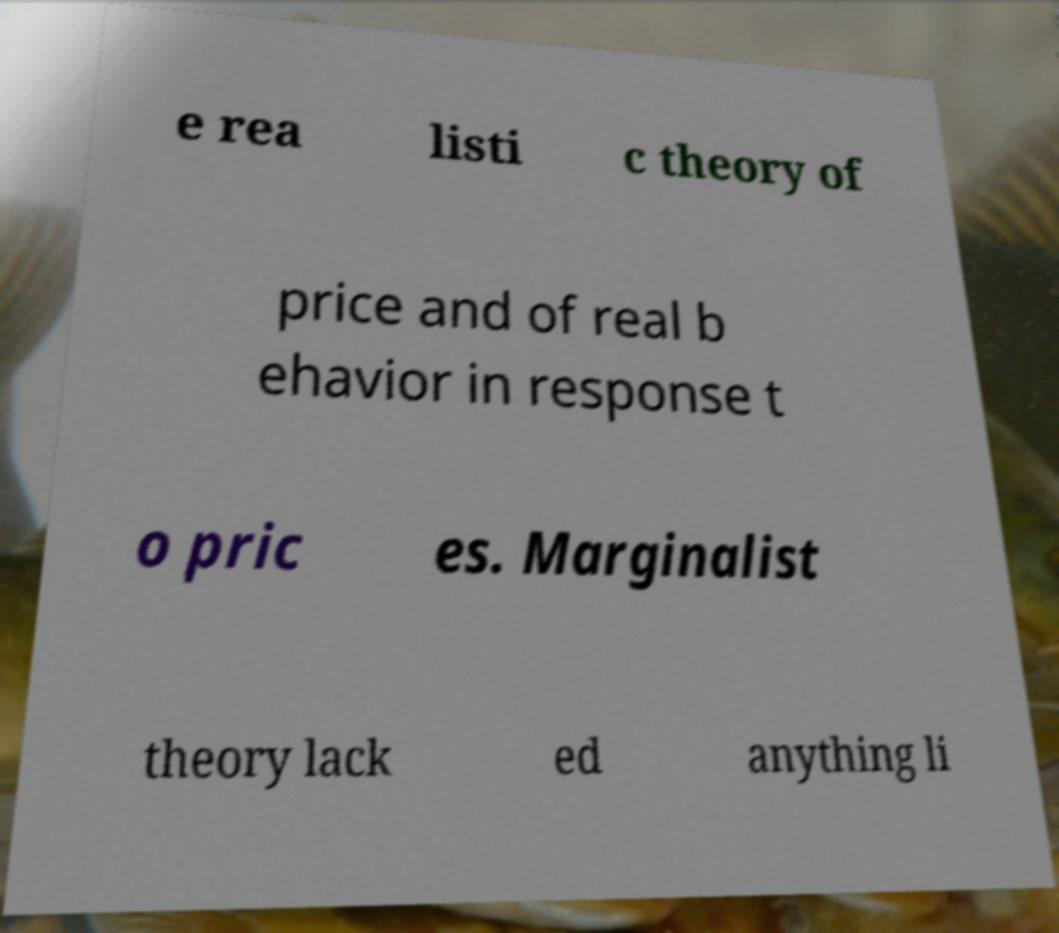Could you assist in decoding the text presented in this image and type it out clearly? e rea listi c theory of price and of real b ehavior in response t o pric es. Marginalist theory lack ed anything li 